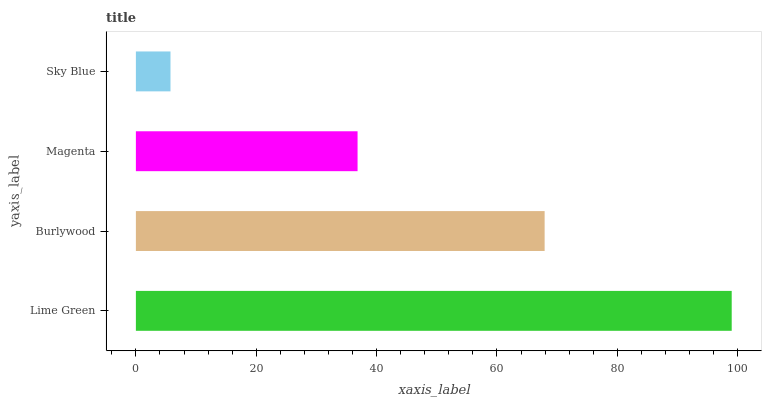Is Sky Blue the minimum?
Answer yes or no. Yes. Is Lime Green the maximum?
Answer yes or no. Yes. Is Burlywood the minimum?
Answer yes or no. No. Is Burlywood the maximum?
Answer yes or no. No. Is Lime Green greater than Burlywood?
Answer yes or no. Yes. Is Burlywood less than Lime Green?
Answer yes or no. Yes. Is Burlywood greater than Lime Green?
Answer yes or no. No. Is Lime Green less than Burlywood?
Answer yes or no. No. Is Burlywood the high median?
Answer yes or no. Yes. Is Magenta the low median?
Answer yes or no. Yes. Is Magenta the high median?
Answer yes or no. No. Is Burlywood the low median?
Answer yes or no. No. 